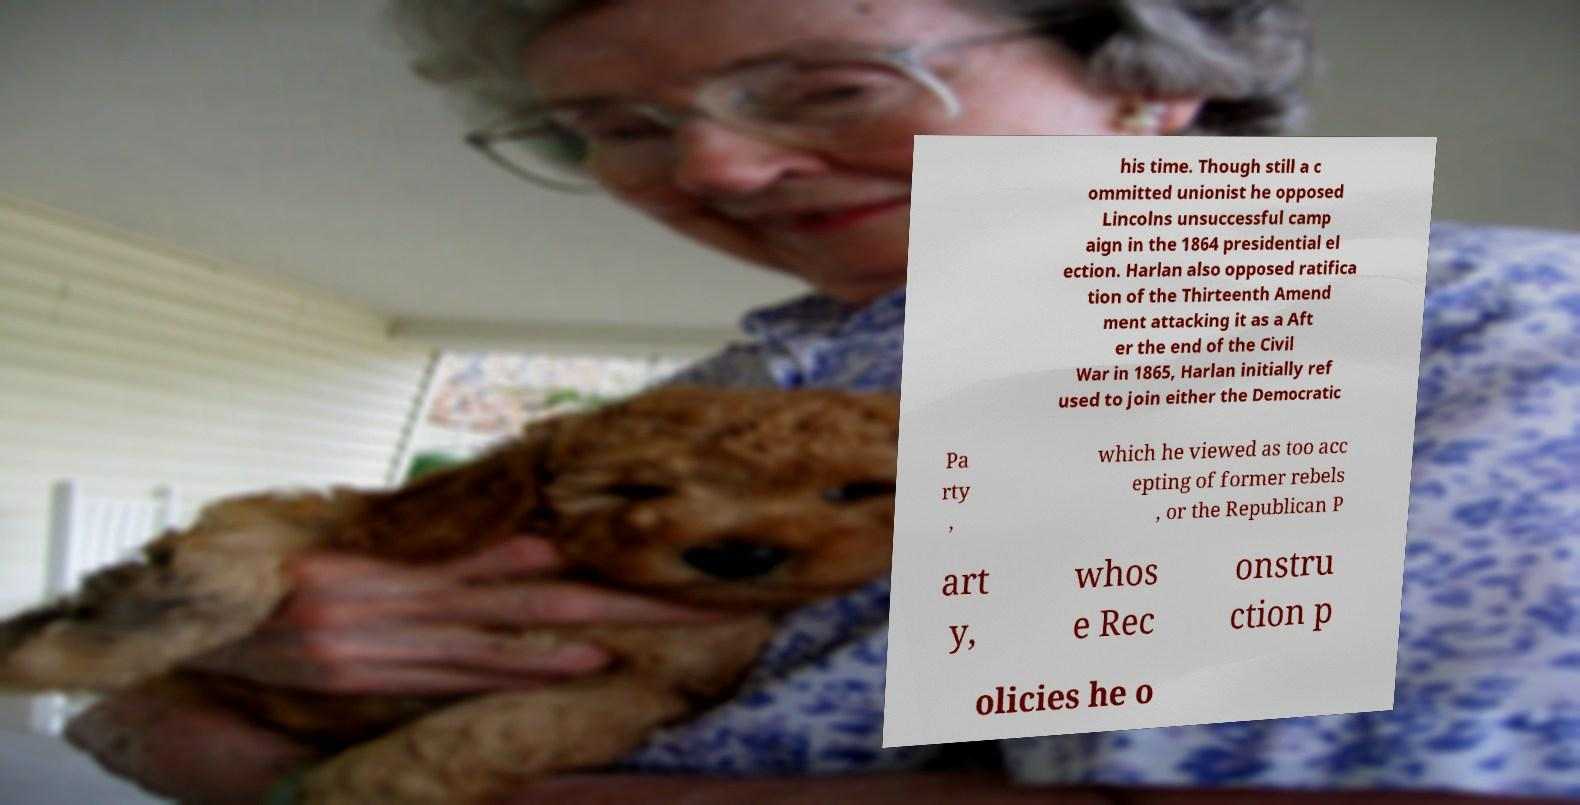What messages or text are displayed in this image? I need them in a readable, typed format. his time. Though still a c ommitted unionist he opposed Lincolns unsuccessful camp aign in the 1864 presidential el ection. Harlan also opposed ratifica tion of the Thirteenth Amend ment attacking it as a Aft er the end of the Civil War in 1865, Harlan initially ref used to join either the Democratic Pa rty , which he viewed as too acc epting of former rebels , or the Republican P art y, whos e Rec onstru ction p olicies he o 